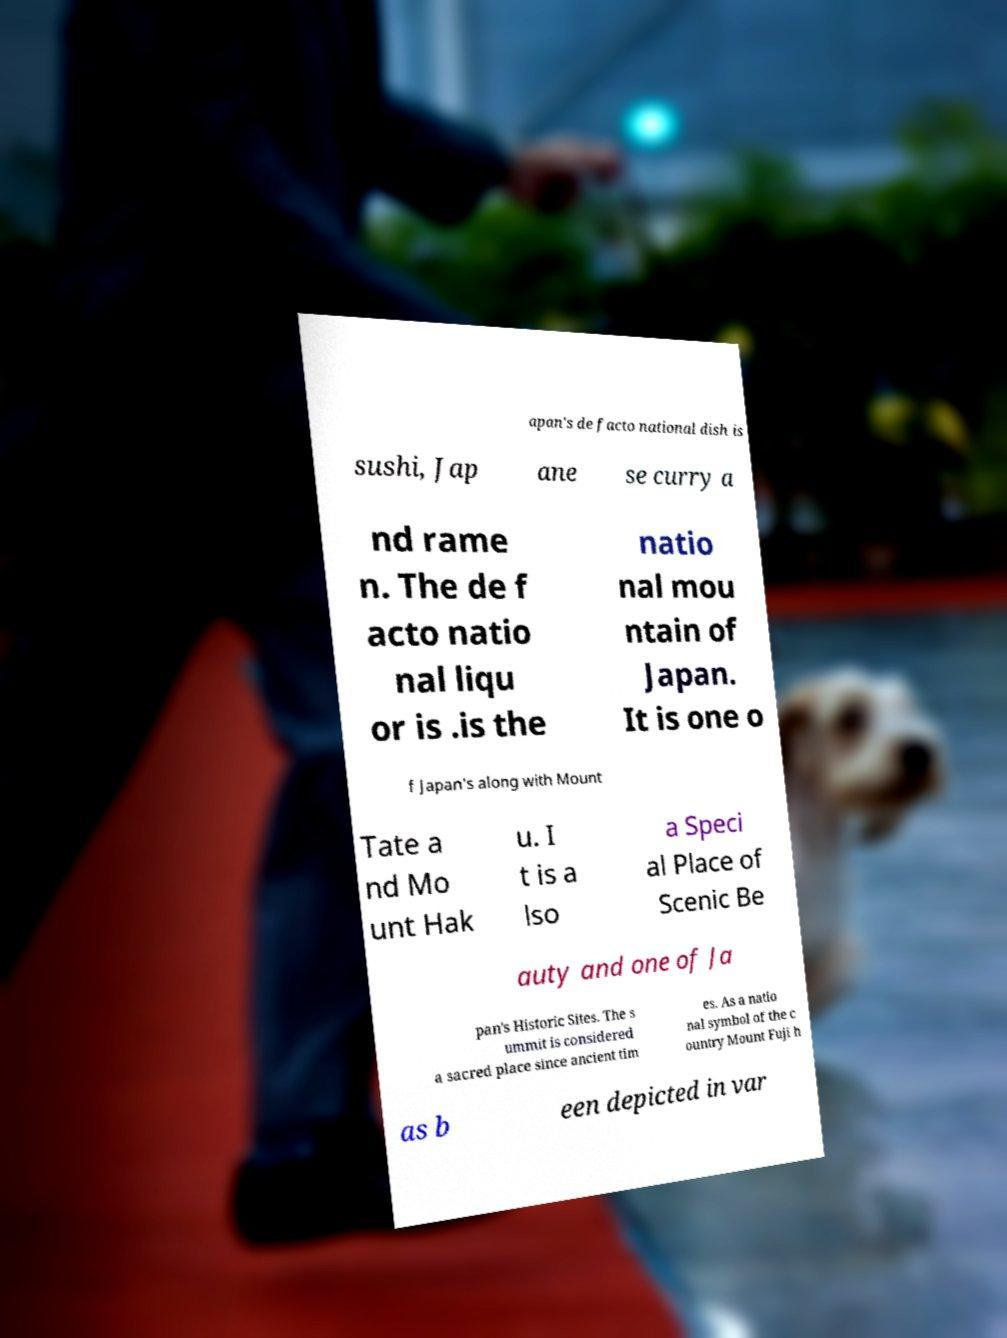For documentation purposes, I need the text within this image transcribed. Could you provide that? apan's de facto national dish is sushi, Jap ane se curry a nd rame n. The de f acto natio nal liqu or is .is the natio nal mou ntain of Japan. It is one o f Japan's along with Mount Tate a nd Mo unt Hak u. I t is a lso a Speci al Place of Scenic Be auty and one of Ja pan's Historic Sites. The s ummit is considered a sacred place since ancient tim es. As a natio nal symbol of the c ountry Mount Fuji h as b een depicted in var 